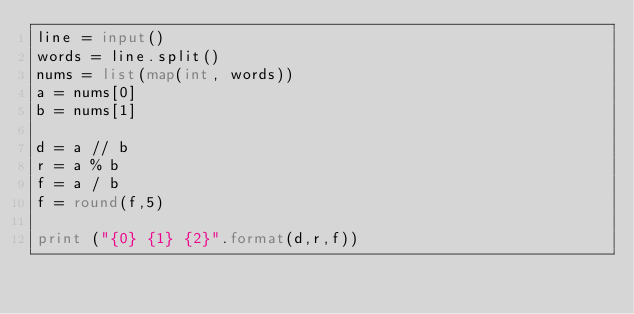Convert code to text. <code><loc_0><loc_0><loc_500><loc_500><_Python_>line = input()
words = line.split()
nums = list(map(int, words))
a = nums[0]
b = nums[1]

d = a // b
r = a % b
f = a / b
f = round(f,5)

print ("{0} {1} {2}".format(d,r,f))</code> 